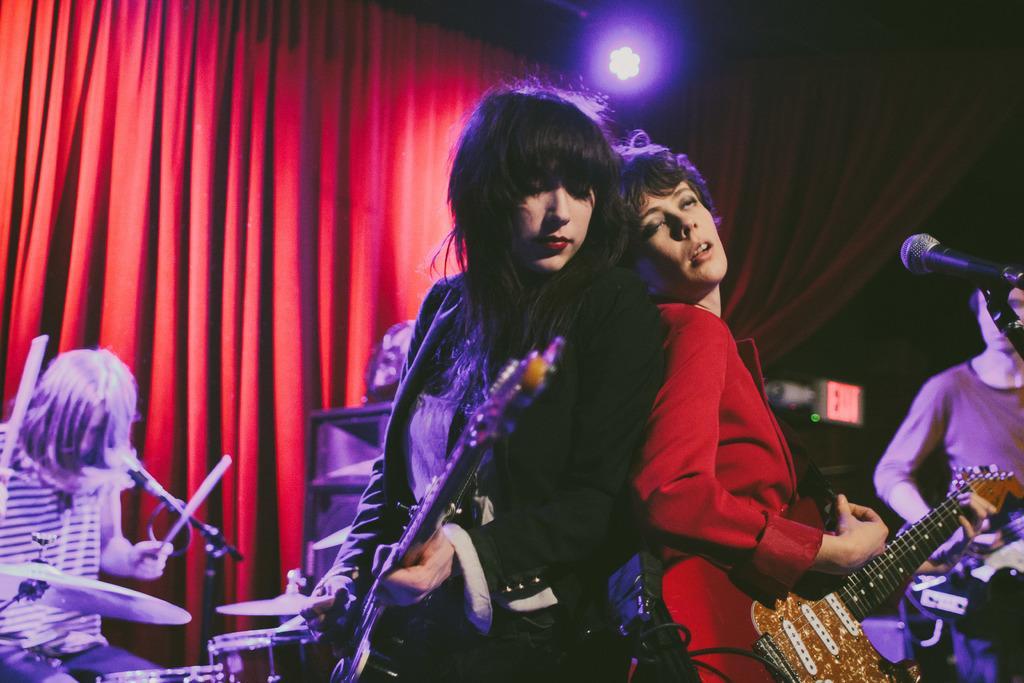Could you give a brief overview of what you see in this image? In this image, we can see people holding guitars and in the background, there are some other people and one of them is holding sticks and there are some musical instruments and mics and there is a curtain. At the top, there is light. 